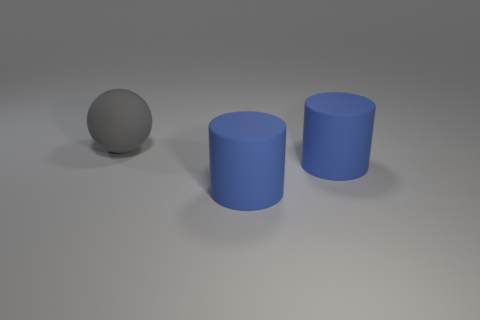Are there an equal number of large rubber spheres behind the ball and gray balls?
Your answer should be very brief. No. How many objects are the same material as the gray sphere?
Your answer should be very brief. 2. Are there any things behind the large gray rubber object?
Ensure brevity in your answer.  No. How many other objects are there of the same size as the gray rubber sphere?
Your answer should be compact. 2. What number of other things are there of the same shape as the gray object?
Provide a succinct answer. 0. How many cylinders are large objects or blue things?
Offer a terse response. 2. What number of matte cylinders are there?
Provide a short and direct response. 2. How many things are either large gray matte things or blue matte objects?
Give a very brief answer. 3. Is the number of large gray matte things less than the number of small cyan objects?
Give a very brief answer. No. How many rubber balls have the same size as the gray thing?
Your response must be concise. 0. 